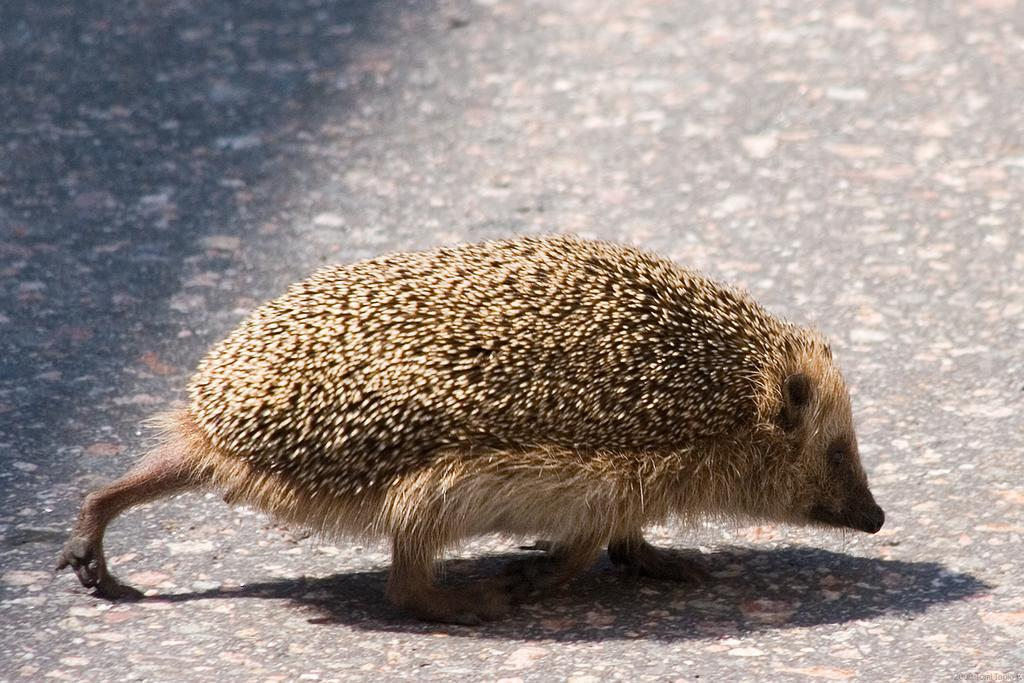What animal is present in the image? There is a porcupine in the image. Where is the porcupine located in the image? The porcupine is standing on the road. What type of home can be seen in the image? There is no home present in the image; it only features a porcupine standing on the road. What kind of beast is interacting with the porcupine in the image? There is no beast interacting with the porcupine in the image; the porcupine is alone on the road. 